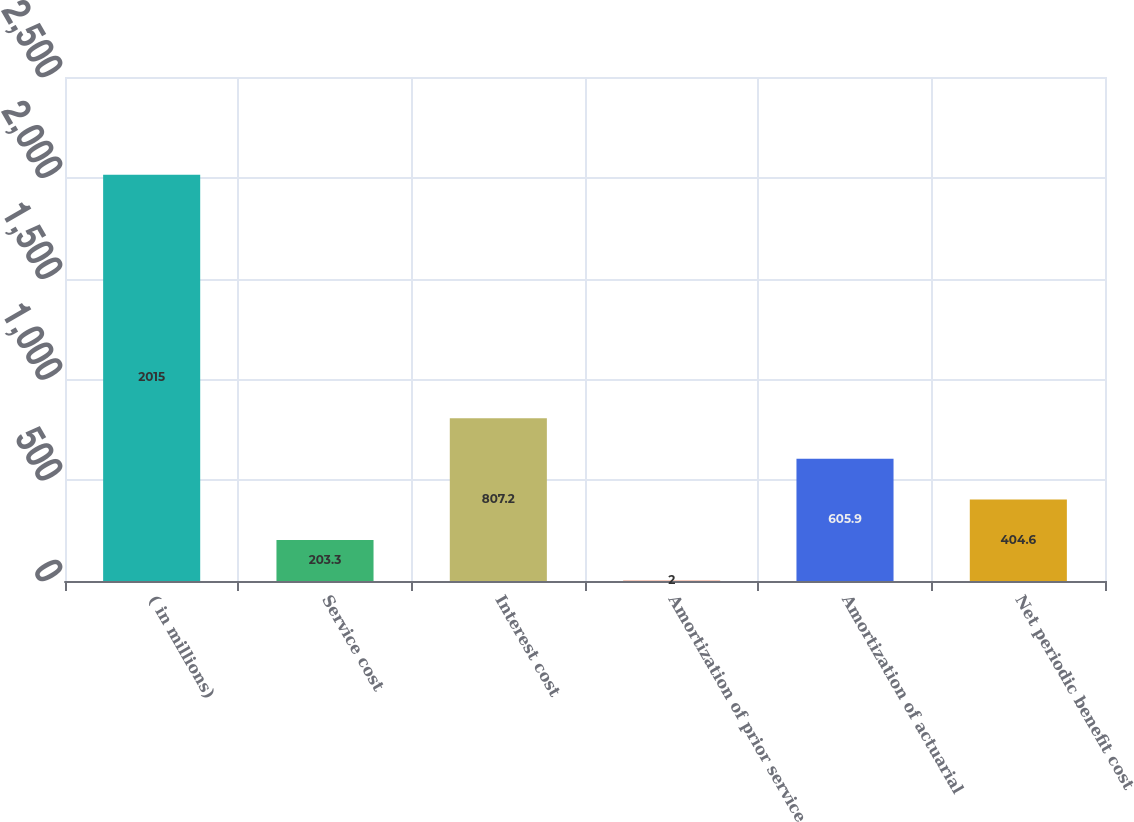Convert chart to OTSL. <chart><loc_0><loc_0><loc_500><loc_500><bar_chart><fcel>( in millions)<fcel>Service cost<fcel>Interest cost<fcel>Amortization of prior service<fcel>Amortization of actuarial<fcel>Net periodic benefit cost<nl><fcel>2015<fcel>203.3<fcel>807.2<fcel>2<fcel>605.9<fcel>404.6<nl></chart> 